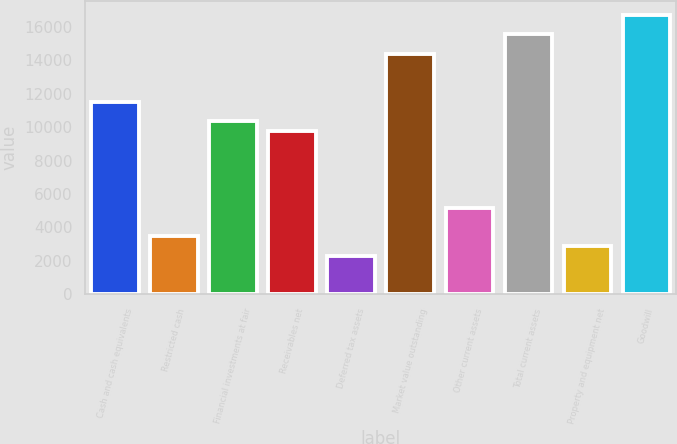Convert chart to OTSL. <chart><loc_0><loc_0><loc_500><loc_500><bar_chart><fcel>Cash and cash equivalents<fcel>Restricted cash<fcel>Financial investments at fair<fcel>Receivables net<fcel>Deferred tax assets<fcel>Market value outstanding<fcel>Other current assets<fcel>Total current assets<fcel>Property and equipment net<fcel>Goodwill<nl><fcel>11524<fcel>3458.6<fcel>10371.8<fcel>9795.7<fcel>2306.4<fcel>14404.5<fcel>5186.9<fcel>15556.7<fcel>2882.5<fcel>16708.9<nl></chart> 